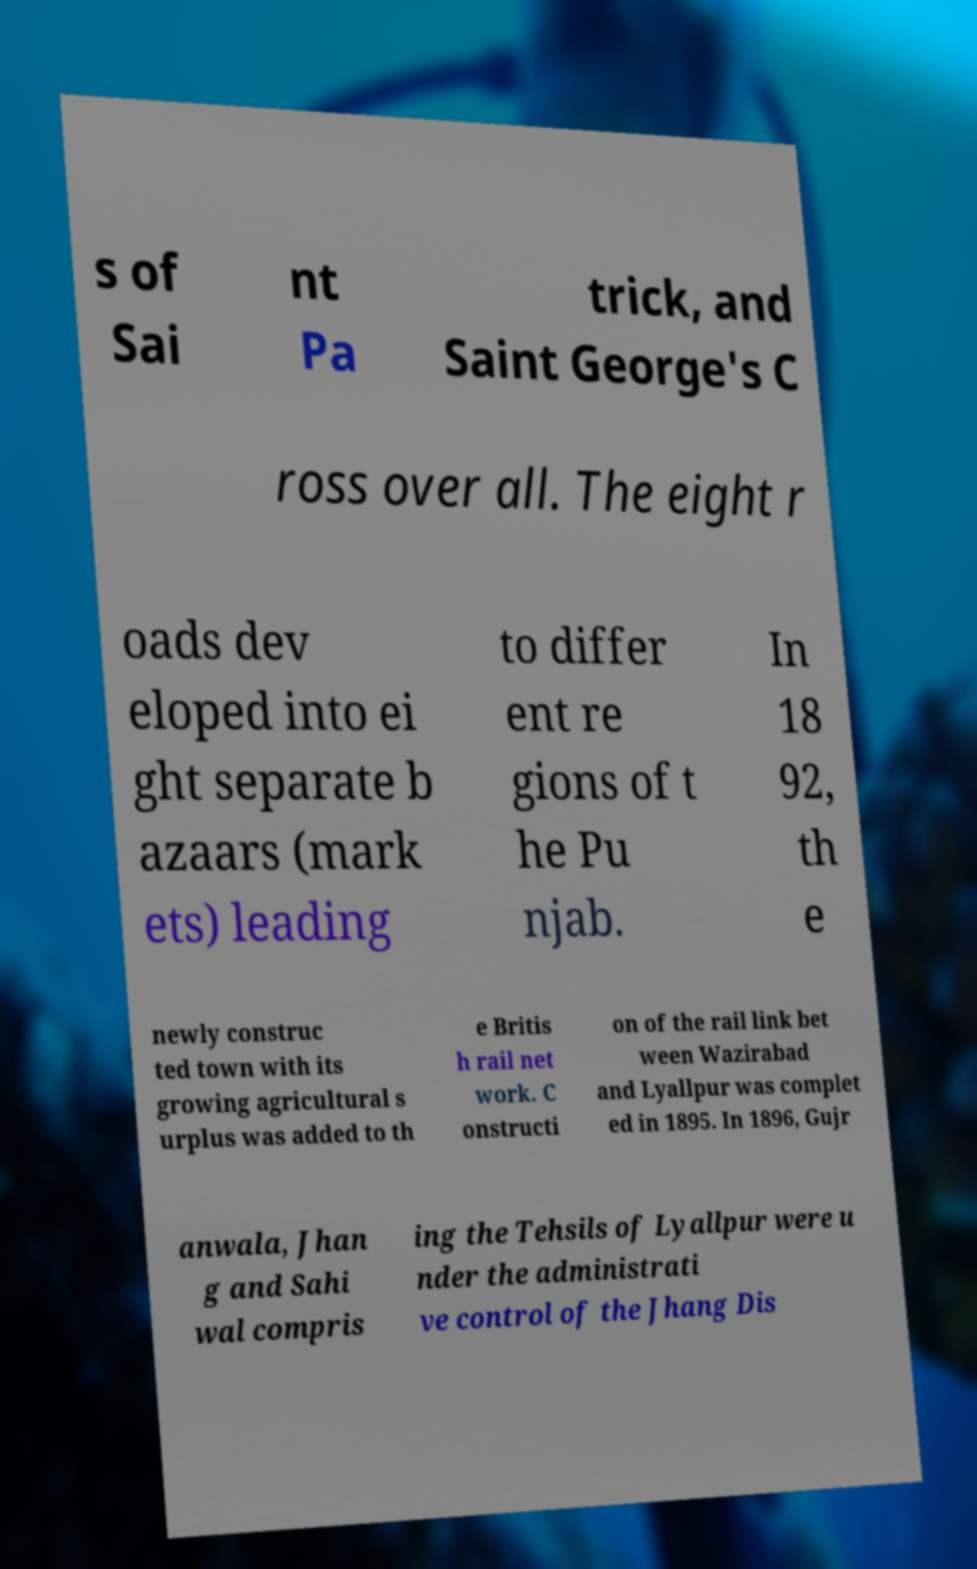Could you extract and type out the text from this image? s of Sai nt Pa trick, and Saint George's C ross over all. The eight r oads dev eloped into ei ght separate b azaars (mark ets) leading to differ ent re gions of t he Pu njab. In 18 92, th e newly construc ted town with its growing agricultural s urplus was added to th e Britis h rail net work. C onstructi on of the rail link bet ween Wazirabad and Lyallpur was complet ed in 1895. In 1896, Gujr anwala, Jhan g and Sahi wal compris ing the Tehsils of Lyallpur were u nder the administrati ve control of the Jhang Dis 